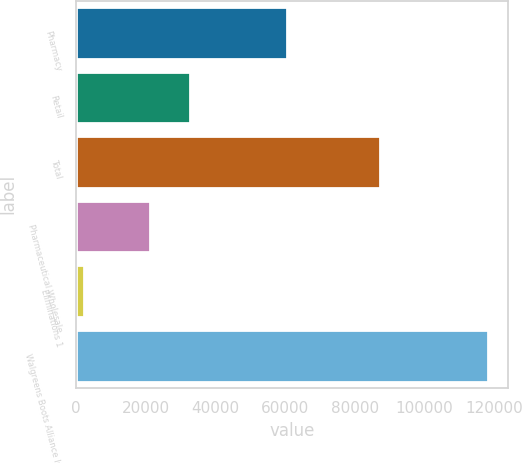Convert chart. <chart><loc_0><loc_0><loc_500><loc_500><bar_chart><fcel>Pharmacy<fcel>Retail<fcel>Total<fcel>Pharmaceutical Wholesale<fcel>Eliminations 1<fcel>Walgreens Boots Alliance Inc<nl><fcel>60608<fcel>32800.5<fcel>87302<fcel>21188<fcel>2089<fcel>118214<nl></chart> 